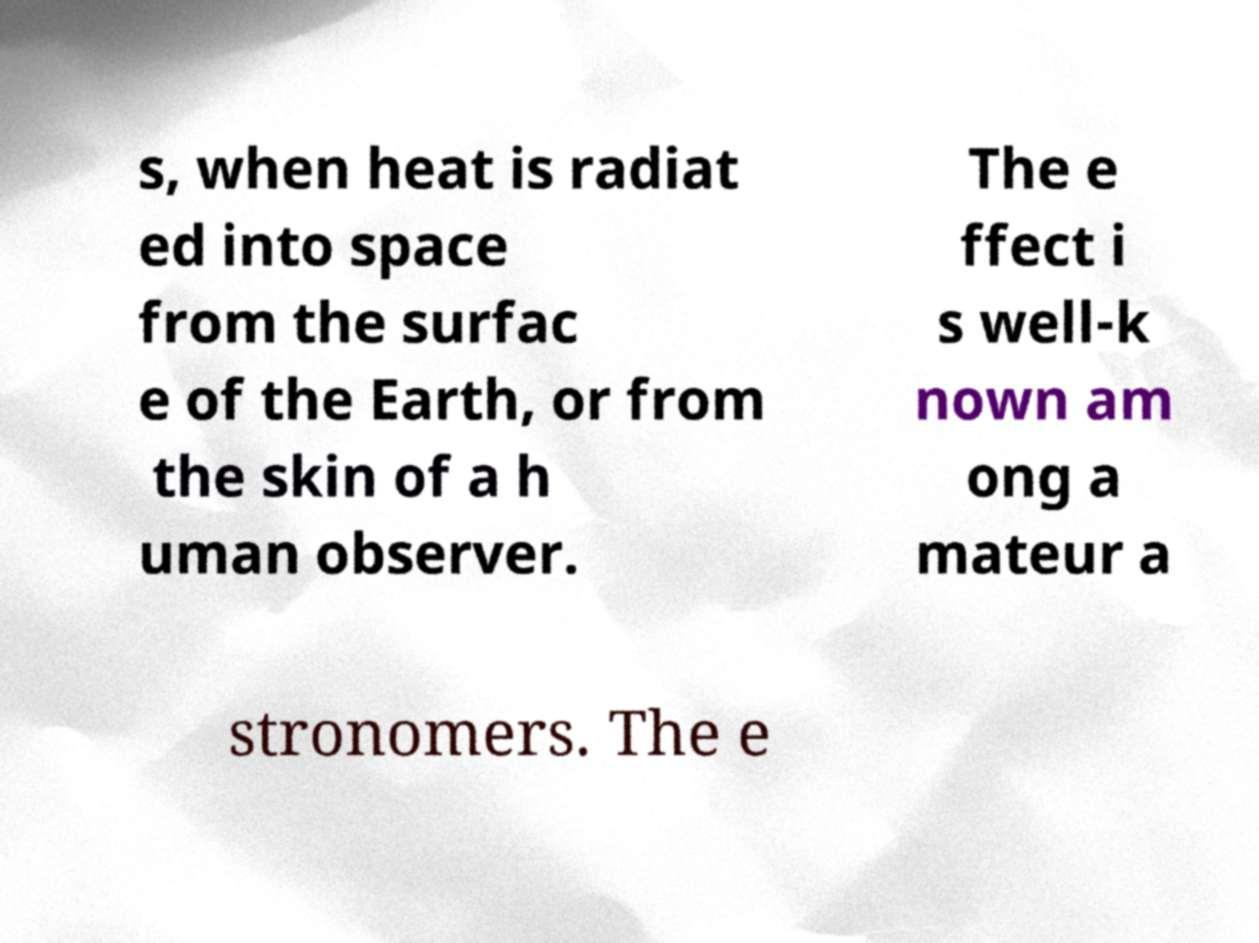Please identify and transcribe the text found in this image. s, when heat is radiat ed into space from the surfac e of the Earth, or from the skin of a h uman observer. The e ffect i s well-k nown am ong a mateur a stronomers. The e 